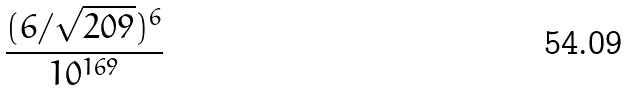<formula> <loc_0><loc_0><loc_500><loc_500>\frac { ( 6 / \sqrt { 2 0 9 } ) ^ { 6 } } { 1 0 ^ { 1 6 9 } }</formula> 